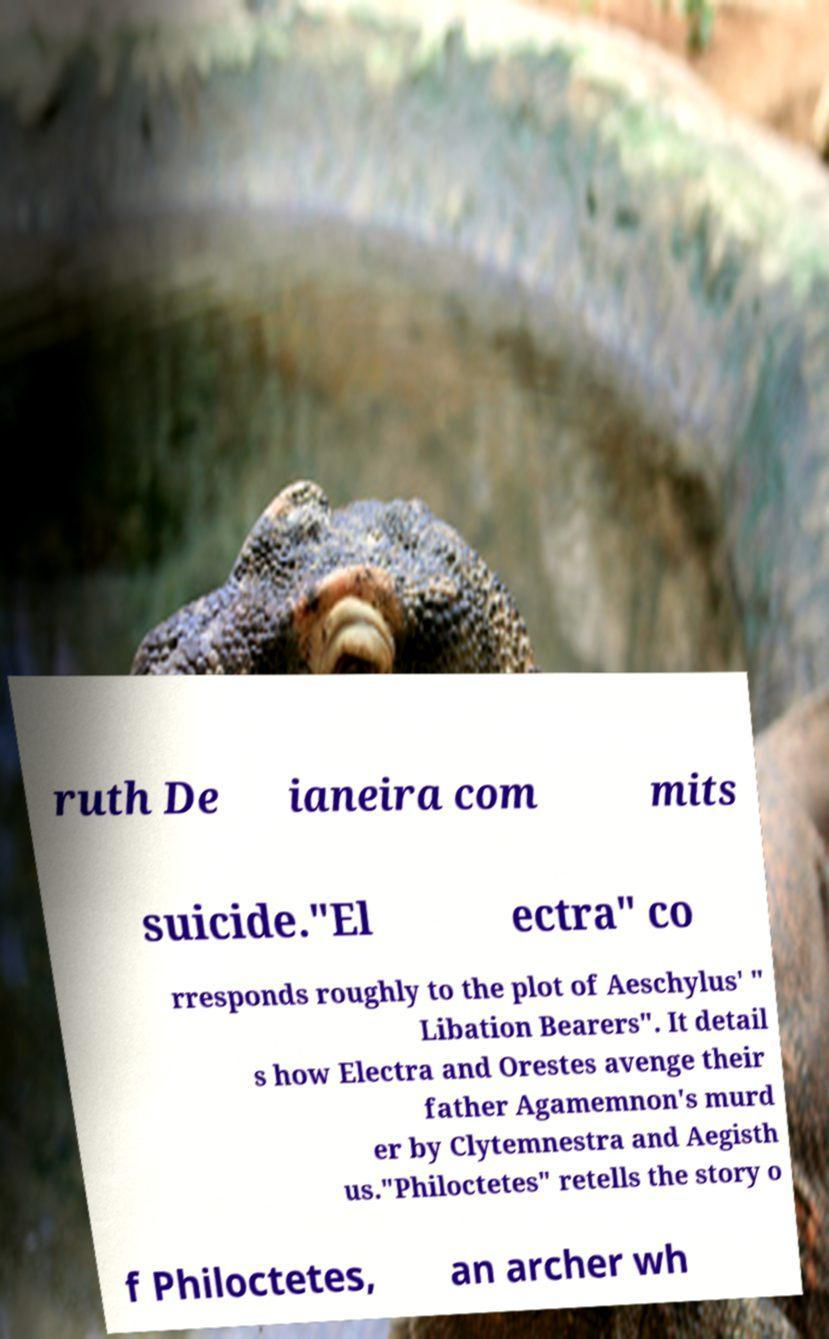Please identify and transcribe the text found in this image. ruth De ianeira com mits suicide."El ectra" co rresponds roughly to the plot of Aeschylus' " Libation Bearers". It detail s how Electra and Orestes avenge their father Agamemnon's murd er by Clytemnestra and Aegisth us."Philoctetes" retells the story o f Philoctetes, an archer wh 